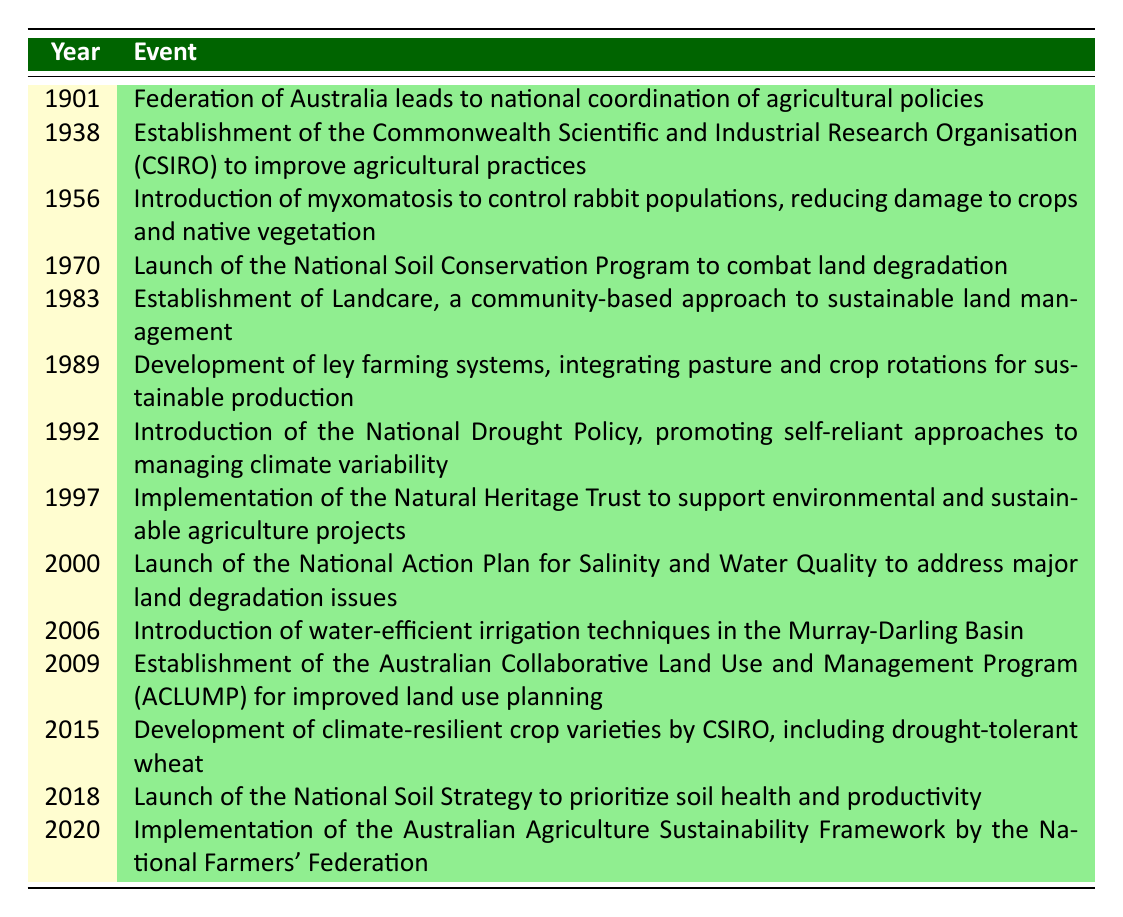What year was the establishment of Landcare? Referring to the timeline, Landcare was established in 1983.
Answer: 1983 What event occurred in 2006? In 2006, water-efficient irrigation techniques were introduced in the Murray-Darling Basin.
Answer: Introduction of water-efficient irrigation techniques in the Murray-Darling Basin How many events were recorded before the year 2000? Counting the events listed before the year 2000, we have 9 events (from 1901 to 1997).
Answer: 9 Was the National Soil Conservation Program launched after 1980? The National Soil Conservation Program was launched in 1970, which is before 1980, so the answer is no.
Answer: No Which two events focused on improving soil health? The events focusing on soil health are the launch of the National Soil Strategy in 2018 and the establishment of the National Soil Conservation Program in 1970.
Answer: National Soil Strategy in 2018 and National Soil Conservation Program in 1970 What was the primary focus of the National Drought Policy introduced in 1992? The National Drought Policy promoted self-reliant approaches to managing climate variability, focusing on resilience.
Answer: Self-reliant approaches to managing climate variability How many years passed between the implementation of the Natural Heritage Trust in 1997 and the launch of the National Soil Strategy in 2018? Calculating the difference between the two years, 2018 - 1997 gives us 21 years.
Answer: 21 years Was the introduction of myxomatosis aimed at controlling native vegetation? The introduction of myxomatosis aimed at controlling rabbit populations to reduce damage to crops and native vegetation, so the statement is true.
Answer: Yes What is the significance of the year 2020 in sustainable agriculture practices according to the table? In 2020, the Australian Agriculture Sustainability Framework was implemented, marking a significant step in developing sustainability practices across agriculture.
Answer: Implementation of the Australian Agriculture Sustainability Framework 